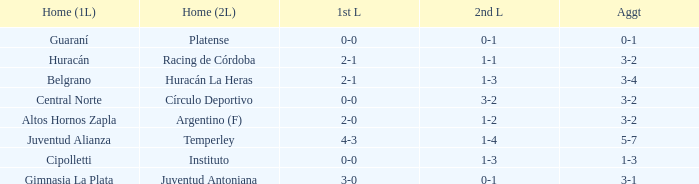Which team played their first leg at home with an aggregate score of 3-4? Belgrano. 